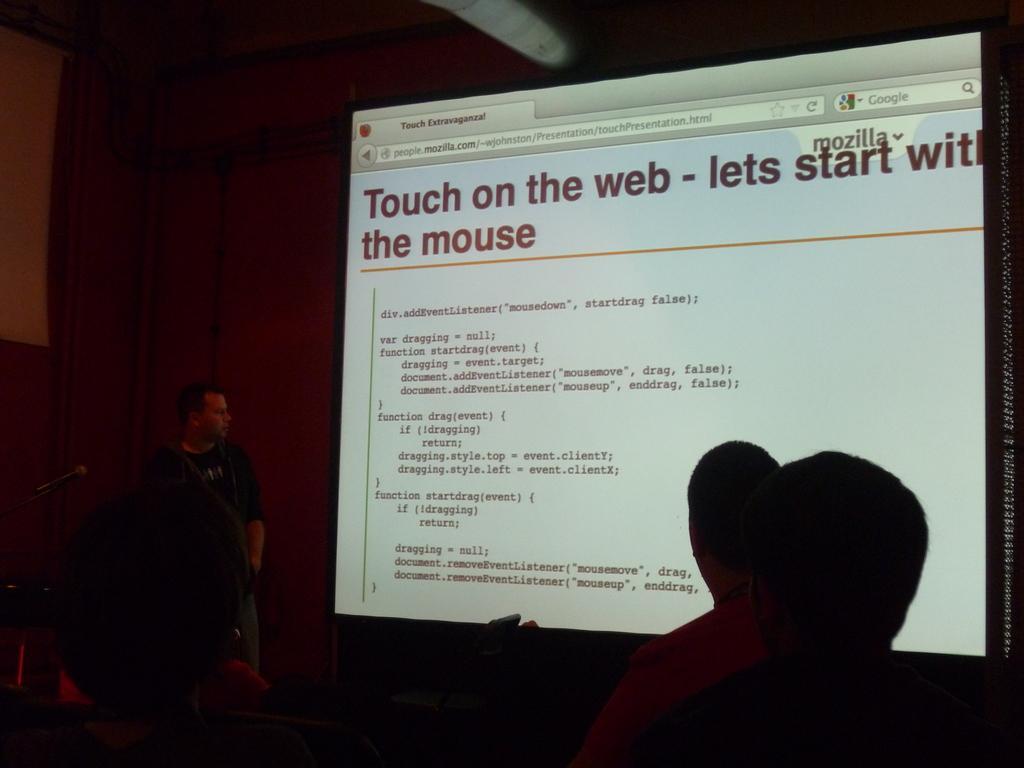Please provide a concise description of this image. In this image in the center there is a screen, on the screen there is text. And on the right side and left side there are some persons, and in the background there is a wall. 